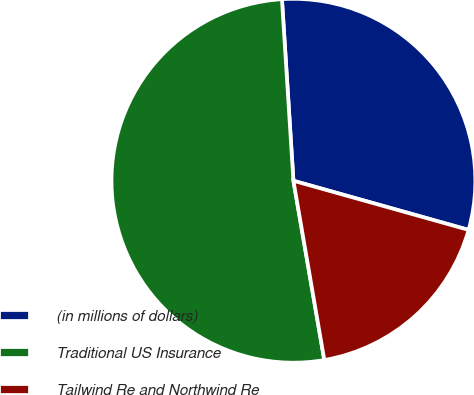<chart> <loc_0><loc_0><loc_500><loc_500><pie_chart><fcel>(in millions of dollars)<fcel>Traditional US Insurance<fcel>Tailwind Re and Northwind Re<nl><fcel>30.36%<fcel>51.71%<fcel>17.93%<nl></chart> 